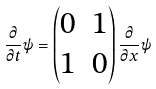<formula> <loc_0><loc_0><loc_500><loc_500>\frac { \partial } { \partial t } \psi = \begin{pmatrix} 0 & 1 \\ 1 & 0 \end{pmatrix} \frac { \partial } { \partial x } \psi</formula> 